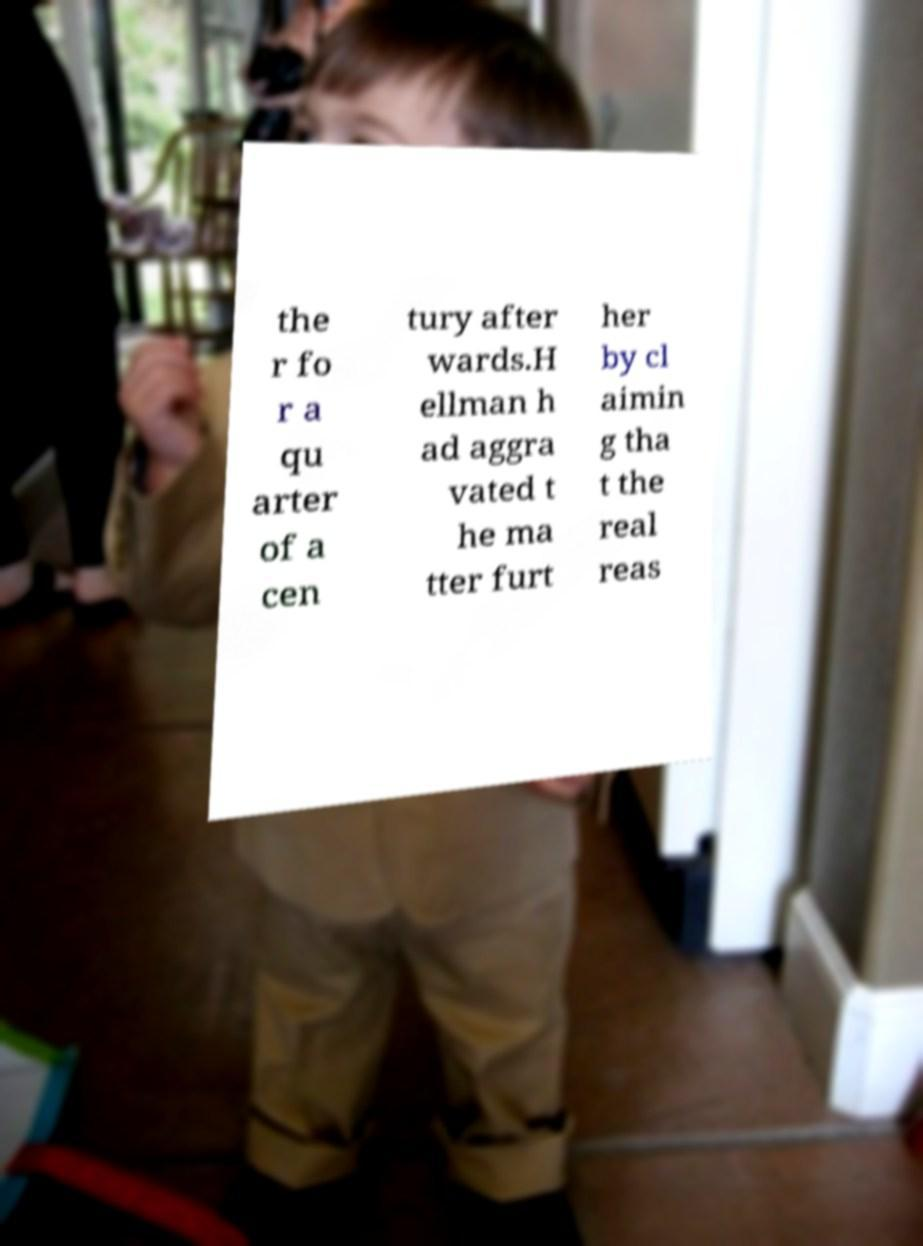For documentation purposes, I need the text within this image transcribed. Could you provide that? the r fo r a qu arter of a cen tury after wards.H ellman h ad aggra vated t he ma tter furt her by cl aimin g tha t the real reas 